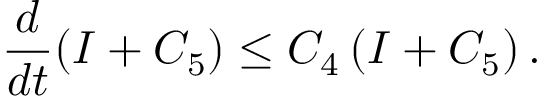<formula> <loc_0><loc_0><loc_500><loc_500>\frac { d } { d t } ( I + C _ { 5 } ) \leq C _ { 4 } \left ( I + C _ { 5 } \right ) .</formula> 